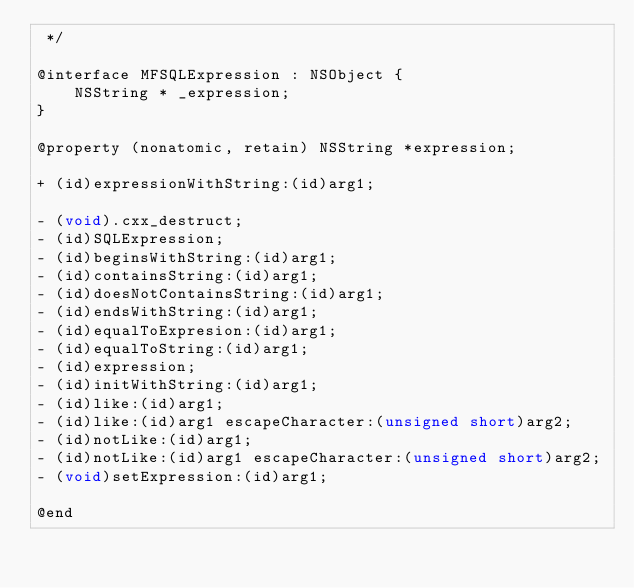Convert code to text. <code><loc_0><loc_0><loc_500><loc_500><_C_> */

@interface MFSQLExpression : NSObject {
    NSString * _expression;
}

@property (nonatomic, retain) NSString *expression;

+ (id)expressionWithString:(id)arg1;

- (void).cxx_destruct;
- (id)SQLExpression;
- (id)beginsWithString:(id)arg1;
- (id)containsString:(id)arg1;
- (id)doesNotContainsString:(id)arg1;
- (id)endsWithString:(id)arg1;
- (id)equalToExpresion:(id)arg1;
- (id)equalToString:(id)arg1;
- (id)expression;
- (id)initWithString:(id)arg1;
- (id)like:(id)arg1;
- (id)like:(id)arg1 escapeCharacter:(unsigned short)arg2;
- (id)notLike:(id)arg1;
- (id)notLike:(id)arg1 escapeCharacter:(unsigned short)arg2;
- (void)setExpression:(id)arg1;

@end
</code> 